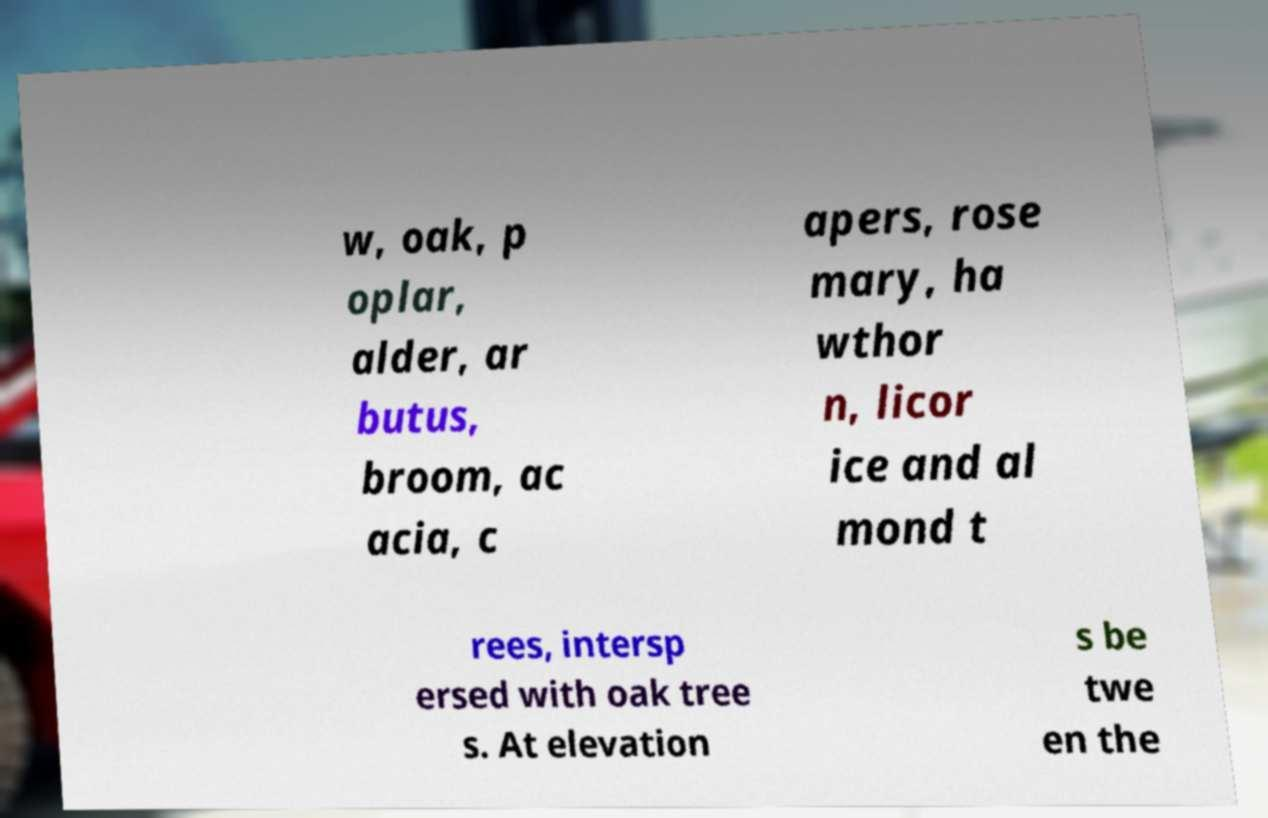Could you extract and type out the text from this image? w, oak, p oplar, alder, ar butus, broom, ac acia, c apers, rose mary, ha wthor n, licor ice and al mond t rees, intersp ersed with oak tree s. At elevation s be twe en the 